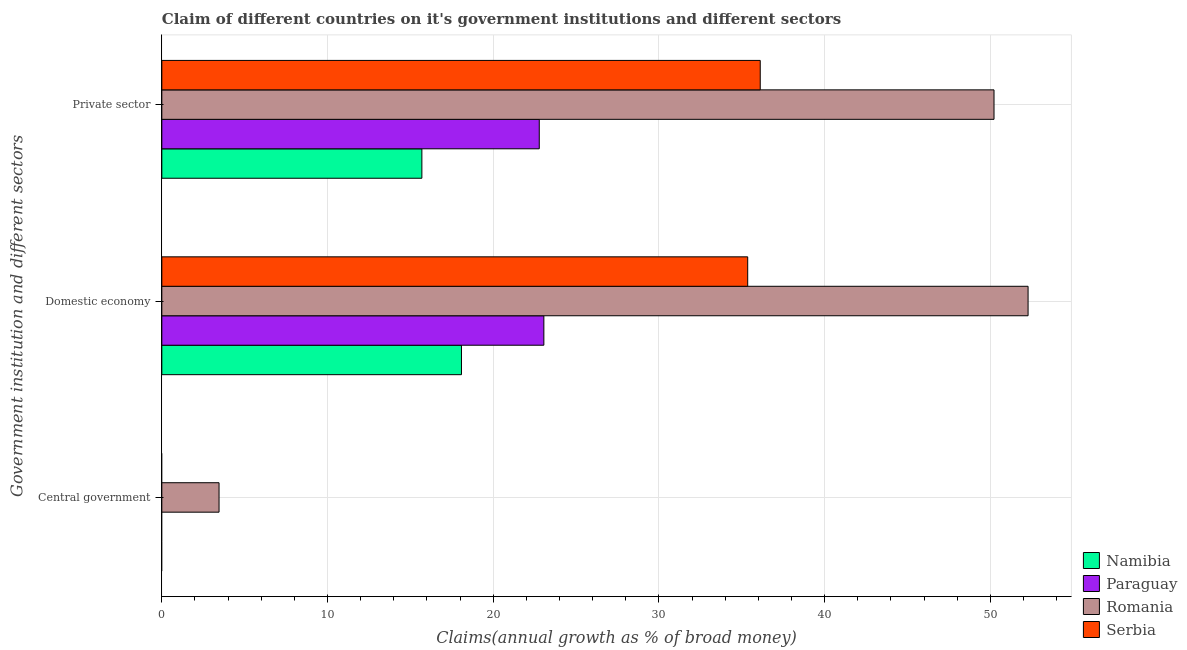Are the number of bars per tick equal to the number of legend labels?
Provide a short and direct response. No. Are the number of bars on each tick of the Y-axis equal?
Offer a terse response. No. How many bars are there on the 2nd tick from the top?
Make the answer very short. 4. What is the label of the 3rd group of bars from the top?
Keep it short and to the point. Central government. What is the percentage of claim on the central government in Paraguay?
Offer a terse response. 0. Across all countries, what is the maximum percentage of claim on the private sector?
Give a very brief answer. 50.22. Across all countries, what is the minimum percentage of claim on the domestic economy?
Offer a terse response. 18.08. In which country was the percentage of claim on the central government maximum?
Provide a succinct answer. Romania. What is the total percentage of claim on the private sector in the graph?
Give a very brief answer. 124.8. What is the difference between the percentage of claim on the private sector in Paraguay and that in Serbia?
Provide a succinct answer. -13.33. What is the difference between the percentage of claim on the private sector in Namibia and the percentage of claim on the domestic economy in Serbia?
Ensure brevity in your answer.  -19.66. What is the average percentage of claim on the private sector per country?
Make the answer very short. 31.2. What is the difference between the percentage of claim on the private sector and percentage of claim on the domestic economy in Paraguay?
Ensure brevity in your answer.  -0.28. What is the ratio of the percentage of claim on the private sector in Paraguay to that in Romania?
Offer a terse response. 0.45. What is the difference between the highest and the second highest percentage of claim on the domestic economy?
Keep it short and to the point. 16.92. What is the difference between the highest and the lowest percentage of claim on the private sector?
Keep it short and to the point. 34.53. Is the sum of the percentage of claim on the domestic economy in Namibia and Paraguay greater than the maximum percentage of claim on the private sector across all countries?
Provide a short and direct response. No. Is it the case that in every country, the sum of the percentage of claim on the central government and percentage of claim on the domestic economy is greater than the percentage of claim on the private sector?
Make the answer very short. No. How many countries are there in the graph?
Offer a very short reply. 4. What is the difference between two consecutive major ticks on the X-axis?
Make the answer very short. 10. Are the values on the major ticks of X-axis written in scientific E-notation?
Give a very brief answer. No. Does the graph contain grids?
Keep it short and to the point. Yes. Where does the legend appear in the graph?
Keep it short and to the point. Bottom right. How many legend labels are there?
Offer a very short reply. 4. How are the legend labels stacked?
Your response must be concise. Vertical. What is the title of the graph?
Your answer should be very brief. Claim of different countries on it's government institutions and different sectors. Does "Jordan" appear as one of the legend labels in the graph?
Your answer should be compact. No. What is the label or title of the X-axis?
Your response must be concise. Claims(annual growth as % of broad money). What is the label or title of the Y-axis?
Your answer should be very brief. Government institution and different sectors. What is the Claims(annual growth as % of broad money) of Romania in Central government?
Keep it short and to the point. 3.45. What is the Claims(annual growth as % of broad money) in Namibia in Domestic economy?
Your answer should be very brief. 18.08. What is the Claims(annual growth as % of broad money) in Paraguay in Domestic economy?
Ensure brevity in your answer.  23.05. What is the Claims(annual growth as % of broad money) in Romania in Domestic economy?
Your answer should be compact. 52.28. What is the Claims(annual growth as % of broad money) of Serbia in Domestic economy?
Provide a succinct answer. 35.36. What is the Claims(annual growth as % of broad money) of Namibia in Private sector?
Your answer should be compact. 15.69. What is the Claims(annual growth as % of broad money) of Paraguay in Private sector?
Provide a short and direct response. 22.78. What is the Claims(annual growth as % of broad money) in Romania in Private sector?
Offer a terse response. 50.22. What is the Claims(annual growth as % of broad money) in Serbia in Private sector?
Your response must be concise. 36.11. Across all Government institution and different sectors, what is the maximum Claims(annual growth as % of broad money) in Namibia?
Provide a short and direct response. 18.08. Across all Government institution and different sectors, what is the maximum Claims(annual growth as % of broad money) in Paraguay?
Provide a succinct answer. 23.05. Across all Government institution and different sectors, what is the maximum Claims(annual growth as % of broad money) in Romania?
Offer a terse response. 52.28. Across all Government institution and different sectors, what is the maximum Claims(annual growth as % of broad money) in Serbia?
Make the answer very short. 36.11. Across all Government institution and different sectors, what is the minimum Claims(annual growth as % of broad money) in Namibia?
Keep it short and to the point. 0. Across all Government institution and different sectors, what is the minimum Claims(annual growth as % of broad money) of Romania?
Provide a short and direct response. 3.45. Across all Government institution and different sectors, what is the minimum Claims(annual growth as % of broad money) in Serbia?
Your answer should be very brief. 0. What is the total Claims(annual growth as % of broad money) of Namibia in the graph?
Give a very brief answer. 33.77. What is the total Claims(annual growth as % of broad money) in Paraguay in the graph?
Offer a very short reply. 45.83. What is the total Claims(annual growth as % of broad money) of Romania in the graph?
Provide a short and direct response. 105.95. What is the total Claims(annual growth as % of broad money) in Serbia in the graph?
Ensure brevity in your answer.  71.47. What is the difference between the Claims(annual growth as % of broad money) in Romania in Central government and that in Domestic economy?
Provide a succinct answer. -48.82. What is the difference between the Claims(annual growth as % of broad money) in Romania in Central government and that in Private sector?
Give a very brief answer. -46.77. What is the difference between the Claims(annual growth as % of broad money) of Namibia in Domestic economy and that in Private sector?
Provide a short and direct response. 2.39. What is the difference between the Claims(annual growth as % of broad money) of Paraguay in Domestic economy and that in Private sector?
Offer a very short reply. 0.28. What is the difference between the Claims(annual growth as % of broad money) in Romania in Domestic economy and that in Private sector?
Offer a terse response. 2.06. What is the difference between the Claims(annual growth as % of broad money) of Serbia in Domestic economy and that in Private sector?
Provide a short and direct response. -0.76. What is the difference between the Claims(annual growth as % of broad money) in Romania in Central government and the Claims(annual growth as % of broad money) in Serbia in Domestic economy?
Your response must be concise. -31.9. What is the difference between the Claims(annual growth as % of broad money) of Romania in Central government and the Claims(annual growth as % of broad money) of Serbia in Private sector?
Make the answer very short. -32.66. What is the difference between the Claims(annual growth as % of broad money) in Namibia in Domestic economy and the Claims(annual growth as % of broad money) in Paraguay in Private sector?
Keep it short and to the point. -4.69. What is the difference between the Claims(annual growth as % of broad money) in Namibia in Domestic economy and the Claims(annual growth as % of broad money) in Romania in Private sector?
Keep it short and to the point. -32.14. What is the difference between the Claims(annual growth as % of broad money) in Namibia in Domestic economy and the Claims(annual growth as % of broad money) in Serbia in Private sector?
Offer a very short reply. -18.03. What is the difference between the Claims(annual growth as % of broad money) of Paraguay in Domestic economy and the Claims(annual growth as % of broad money) of Romania in Private sector?
Your answer should be very brief. -27.17. What is the difference between the Claims(annual growth as % of broad money) in Paraguay in Domestic economy and the Claims(annual growth as % of broad money) in Serbia in Private sector?
Provide a short and direct response. -13.06. What is the difference between the Claims(annual growth as % of broad money) of Romania in Domestic economy and the Claims(annual growth as % of broad money) of Serbia in Private sector?
Keep it short and to the point. 16.16. What is the average Claims(annual growth as % of broad money) in Namibia per Government institution and different sectors?
Give a very brief answer. 11.26. What is the average Claims(annual growth as % of broad money) in Paraguay per Government institution and different sectors?
Your response must be concise. 15.28. What is the average Claims(annual growth as % of broad money) in Romania per Government institution and different sectors?
Offer a terse response. 35.32. What is the average Claims(annual growth as % of broad money) in Serbia per Government institution and different sectors?
Provide a succinct answer. 23.82. What is the difference between the Claims(annual growth as % of broad money) in Namibia and Claims(annual growth as % of broad money) in Paraguay in Domestic economy?
Make the answer very short. -4.97. What is the difference between the Claims(annual growth as % of broad money) of Namibia and Claims(annual growth as % of broad money) of Romania in Domestic economy?
Your response must be concise. -34.19. What is the difference between the Claims(annual growth as % of broad money) of Namibia and Claims(annual growth as % of broad money) of Serbia in Domestic economy?
Your answer should be compact. -17.27. What is the difference between the Claims(annual growth as % of broad money) of Paraguay and Claims(annual growth as % of broad money) of Romania in Domestic economy?
Offer a very short reply. -29.22. What is the difference between the Claims(annual growth as % of broad money) of Paraguay and Claims(annual growth as % of broad money) of Serbia in Domestic economy?
Offer a terse response. -12.3. What is the difference between the Claims(annual growth as % of broad money) in Romania and Claims(annual growth as % of broad money) in Serbia in Domestic economy?
Offer a very short reply. 16.92. What is the difference between the Claims(annual growth as % of broad money) in Namibia and Claims(annual growth as % of broad money) in Paraguay in Private sector?
Keep it short and to the point. -7.08. What is the difference between the Claims(annual growth as % of broad money) in Namibia and Claims(annual growth as % of broad money) in Romania in Private sector?
Your response must be concise. -34.53. What is the difference between the Claims(annual growth as % of broad money) in Namibia and Claims(annual growth as % of broad money) in Serbia in Private sector?
Provide a succinct answer. -20.42. What is the difference between the Claims(annual growth as % of broad money) of Paraguay and Claims(annual growth as % of broad money) of Romania in Private sector?
Your answer should be very brief. -27.44. What is the difference between the Claims(annual growth as % of broad money) in Paraguay and Claims(annual growth as % of broad money) in Serbia in Private sector?
Provide a short and direct response. -13.33. What is the difference between the Claims(annual growth as % of broad money) in Romania and Claims(annual growth as % of broad money) in Serbia in Private sector?
Ensure brevity in your answer.  14.11. What is the ratio of the Claims(annual growth as % of broad money) in Romania in Central government to that in Domestic economy?
Offer a very short reply. 0.07. What is the ratio of the Claims(annual growth as % of broad money) in Romania in Central government to that in Private sector?
Your answer should be very brief. 0.07. What is the ratio of the Claims(annual growth as % of broad money) in Namibia in Domestic economy to that in Private sector?
Give a very brief answer. 1.15. What is the ratio of the Claims(annual growth as % of broad money) of Paraguay in Domestic economy to that in Private sector?
Your answer should be compact. 1.01. What is the ratio of the Claims(annual growth as % of broad money) in Romania in Domestic economy to that in Private sector?
Your answer should be compact. 1.04. What is the ratio of the Claims(annual growth as % of broad money) of Serbia in Domestic economy to that in Private sector?
Offer a terse response. 0.98. What is the difference between the highest and the second highest Claims(annual growth as % of broad money) of Romania?
Your answer should be very brief. 2.06. What is the difference between the highest and the lowest Claims(annual growth as % of broad money) of Namibia?
Your answer should be very brief. 18.08. What is the difference between the highest and the lowest Claims(annual growth as % of broad money) in Paraguay?
Provide a succinct answer. 23.05. What is the difference between the highest and the lowest Claims(annual growth as % of broad money) in Romania?
Make the answer very short. 48.82. What is the difference between the highest and the lowest Claims(annual growth as % of broad money) in Serbia?
Offer a terse response. 36.11. 